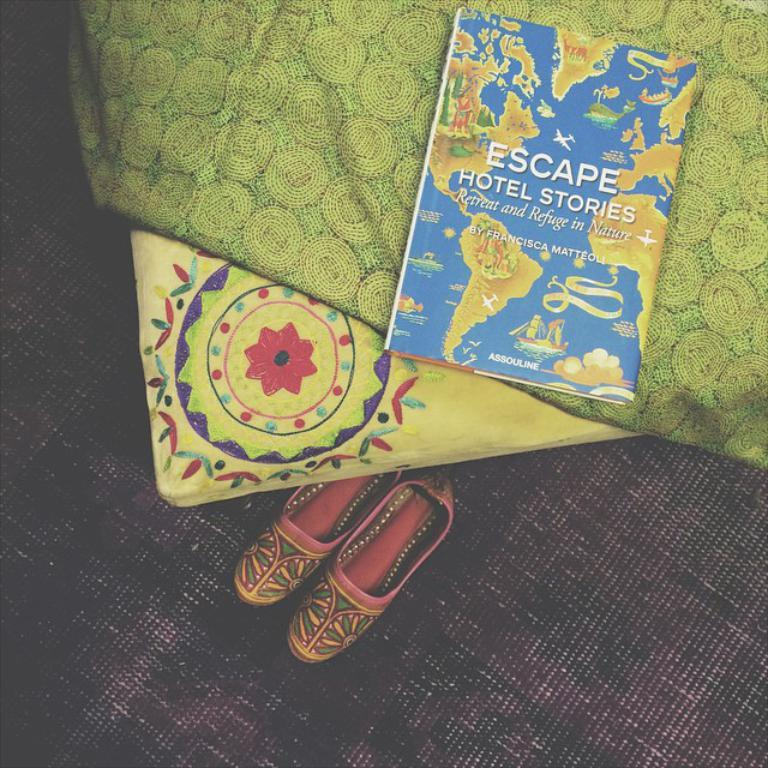<image>
Relay a brief, clear account of the picture shown. The book "Escape! Hotel Stories" sitting on a bed. 